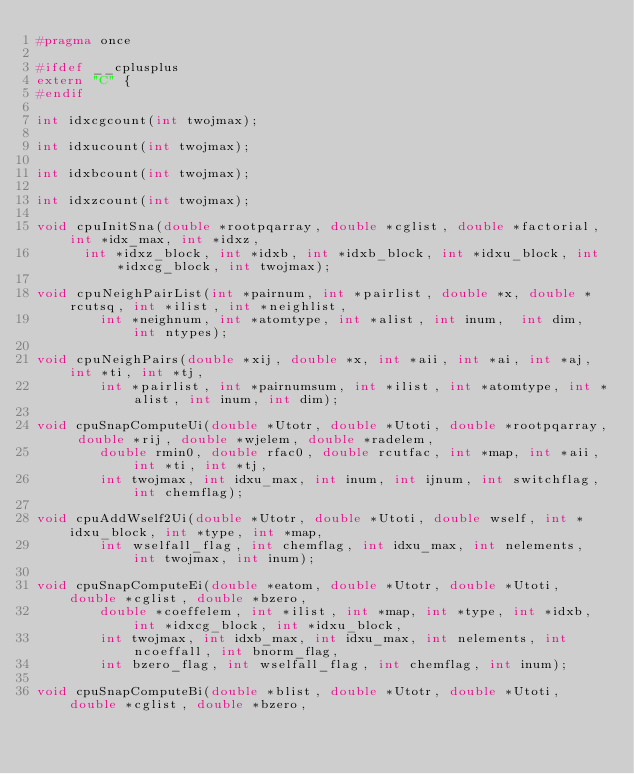<code> <loc_0><loc_0><loc_500><loc_500><_C_>#pragma once

#ifdef __cplusplus
extern "C" {
#endif

int idxcgcount(int twojmax);

int idxucount(int twojmax);

int idxbcount(int twojmax);

int idxzcount(int twojmax);

void cpuInitSna(double *rootpqarray, double *cglist, double *factorial, int *idx_max, int *idxz, 
      int *idxz_block, int *idxb, int *idxb_block, int *idxu_block, int *idxcg_block, int twojmax);

void cpuNeighPairList(int *pairnum, int *pairlist, double *x, double *rcutsq, int *ilist, int *neighlist, 
        int *neighnum, int *atomtype, int *alist, int inum,  int dim, int ntypes);

void cpuNeighPairs(double *xij, double *x, int *aii, int *ai, int *aj,  int *ti, int *tj, 
        int *pairlist, int *pairnumsum, int *ilist, int *atomtype, int *alist, int inum, int dim);

void cpuSnapComputeUi(double *Utotr, double *Utoti, double *rootpqarray, double *rij, double *wjelem, double *radelem, 
        double rmin0, double rfac0, double rcutfac, int *map, int *aii, int *ti, int *tj, 
        int twojmax, int idxu_max, int inum, int ijnum, int switchflag, int chemflag);

void cpuAddWself2Ui(double *Utotr, double *Utoti, double wself, int *idxu_block, int *type, int *map, 
        int wselfall_flag, int chemflag, int idxu_max, int nelements, int twojmax, int inum);

void cpuSnapComputeEi(double *eatom, double *Utotr, double *Utoti, double *cglist, double *bzero, 
        double *coeffelem, int *ilist, int *map, int *type, int *idxb, int *idxcg_block, int *idxu_block, 
        int twojmax, int idxb_max, int idxu_max, int nelements, int ncoeffall, int bnorm_flag, 
        int bzero_flag, int wselfall_flag, int chemflag, int inum);

void cpuSnapComputeBi(double *blist, double *Utotr, double *Utoti, double *cglist, double *bzero, </code> 